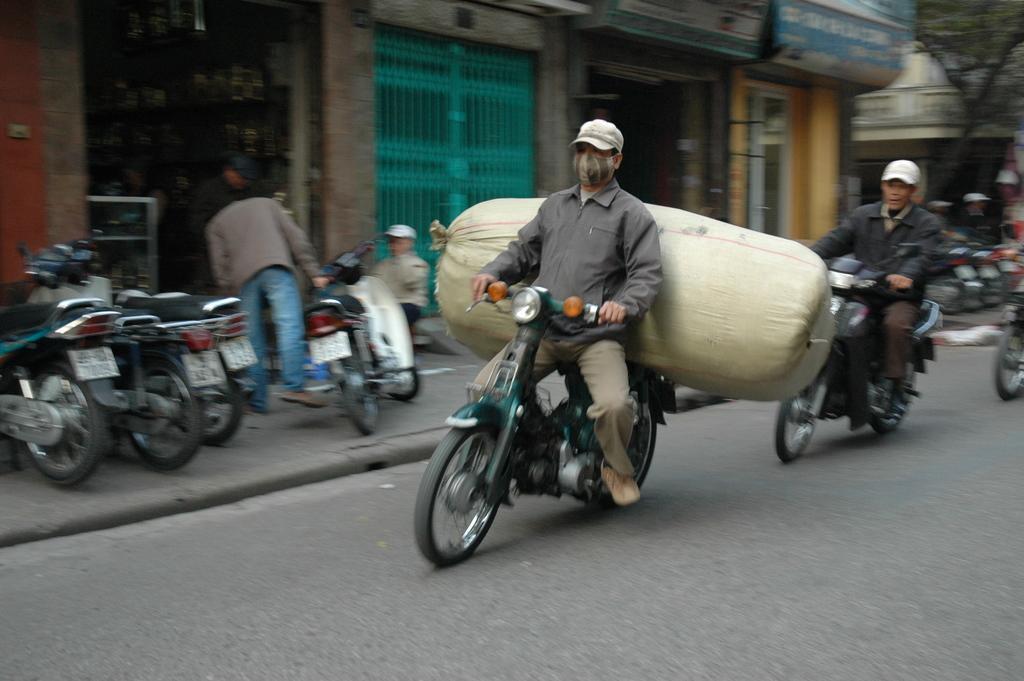Could you give a brief overview of what you see in this image? In this picture there is a man riding a bike, holding a luggage behind him. There are some motorcycles Parked here. In the background, there is another one riding a scooty. We can observe a building here. 